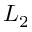<formula> <loc_0><loc_0><loc_500><loc_500>L _ { 2 }</formula> 